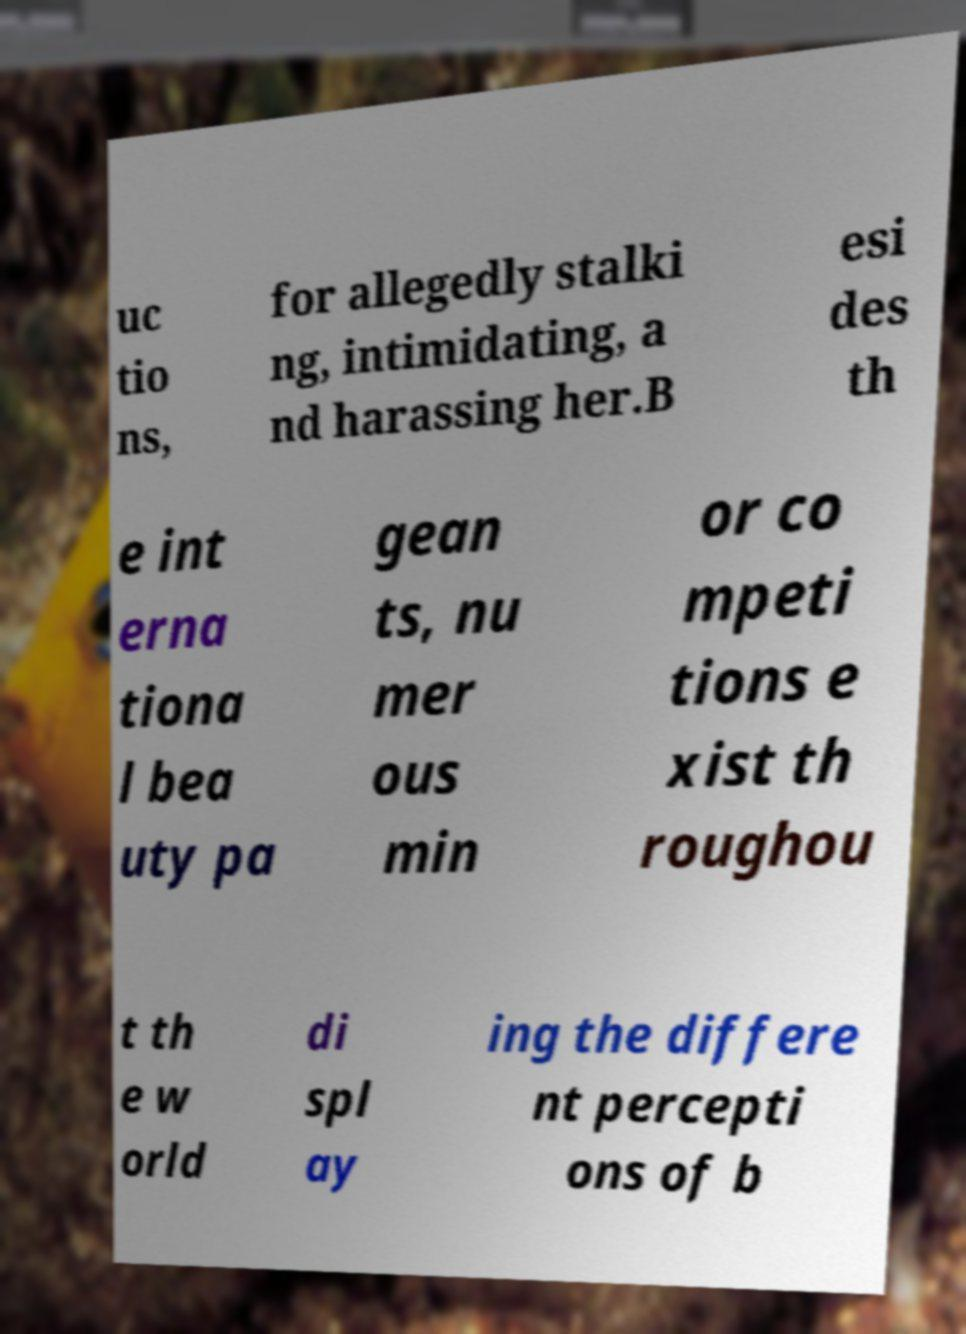Could you extract and type out the text from this image? uc tio ns, for allegedly stalki ng, intimidating, a nd harassing her.B esi des th e int erna tiona l bea uty pa gean ts, nu mer ous min or co mpeti tions e xist th roughou t th e w orld di spl ay ing the differe nt percepti ons of b 